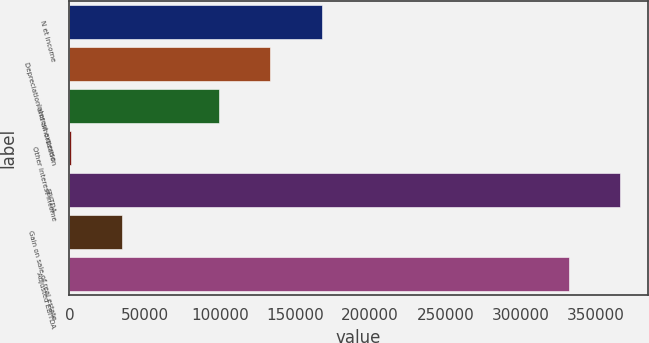Convert chart. <chart><loc_0><loc_0><loc_500><loc_500><bar_chart><fcel>N et income<fcel>Depreciation and amortization<fcel>Interest expense<fcel>Other interest income<fcel>EBITDA<fcel>Gain on sale of real estate<fcel>Adjusted EBITDA<nl><fcel>167872<fcel>133518<fcel>99163<fcel>919<fcel>366248<fcel>35273.6<fcel>331893<nl></chart> 